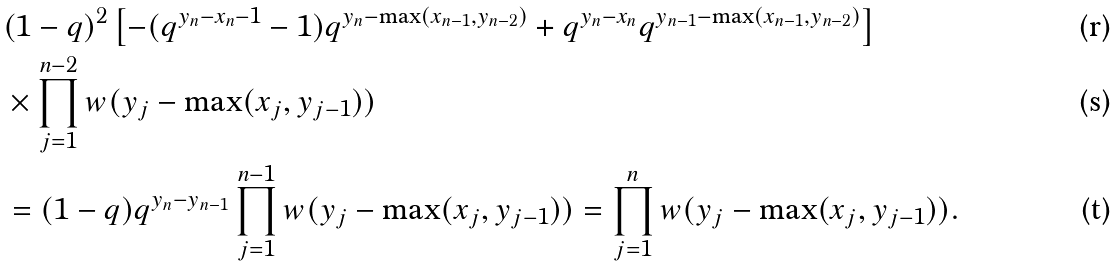<formula> <loc_0><loc_0><loc_500><loc_500>& ( 1 - q ) ^ { 2 } \left [ - ( q ^ { y _ { n } - x _ { n } - 1 } - 1 ) q ^ { y _ { n } - \max ( x _ { n - 1 } , y _ { n - 2 } ) } + q ^ { y _ { n } - x _ { n } } q ^ { y _ { n - 1 } - \max ( x _ { n - 1 } , y _ { n - 2 } ) } \right ] \\ & \times \prod _ { j = 1 } ^ { n - 2 } w ( y _ { j } - \max ( x _ { j } , y _ { j - 1 } ) ) \\ & = ( 1 - q ) q ^ { y _ { n } - y _ { n - 1 } } \prod _ { j = 1 } ^ { n - 1 } w ( y _ { j } - \max ( x _ { j } , y _ { j - 1 } ) ) = \prod _ { j = 1 } ^ { n } w ( y _ { j } - \max ( x _ { j } , y _ { j - 1 } ) ) .</formula> 